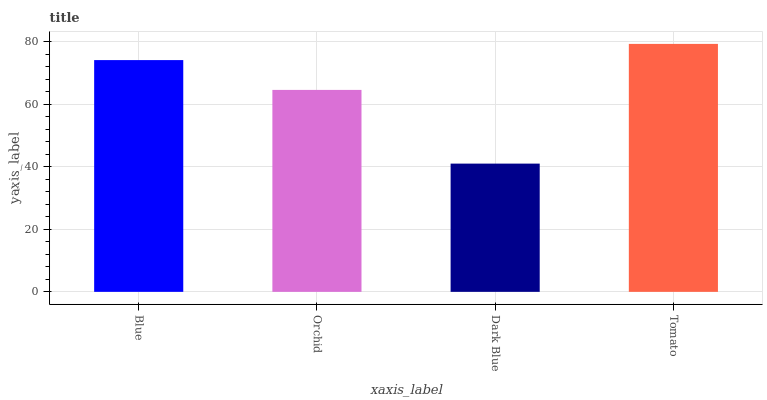Is Dark Blue the minimum?
Answer yes or no. Yes. Is Tomato the maximum?
Answer yes or no. Yes. Is Orchid the minimum?
Answer yes or no. No. Is Orchid the maximum?
Answer yes or no. No. Is Blue greater than Orchid?
Answer yes or no. Yes. Is Orchid less than Blue?
Answer yes or no. Yes. Is Orchid greater than Blue?
Answer yes or no. No. Is Blue less than Orchid?
Answer yes or no. No. Is Blue the high median?
Answer yes or no. Yes. Is Orchid the low median?
Answer yes or no. Yes. Is Tomato the high median?
Answer yes or no. No. Is Tomato the low median?
Answer yes or no. No. 